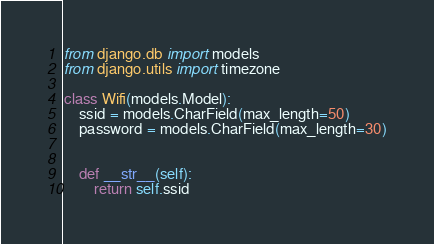Convert code to text. <code><loc_0><loc_0><loc_500><loc_500><_Python_>from django.db import models
from django.utils import timezone

class Wifi(models.Model):
    ssid = models.CharField(max_length=50)
    password = models.CharField(max_length=30)


    def __str__(self):
        return self.ssid
</code> 